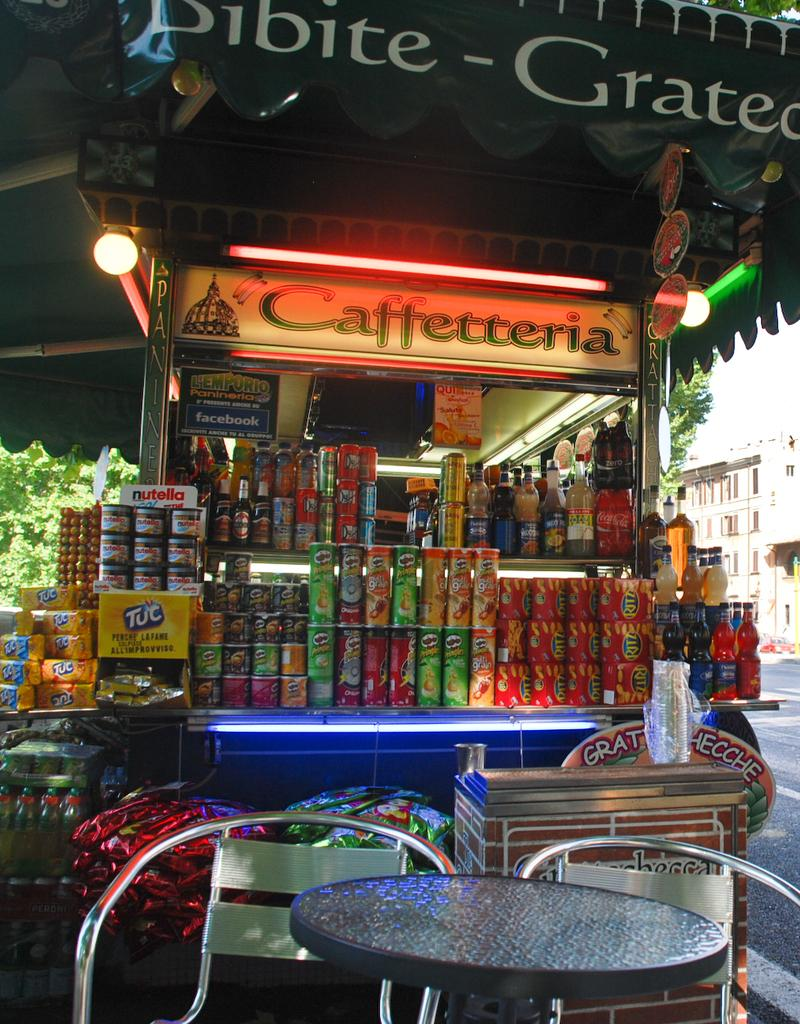<image>
Write a terse but informative summary of the picture. A food truck in a foreign country with a Caffetteria sign 